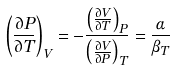Convert formula to latex. <formula><loc_0><loc_0><loc_500><loc_500>\left ( { \frac { \partial P } { \partial T } } \right ) _ { V } = - { \frac { \left ( { \frac { \partial V } { \partial T } } \right ) _ { P } } { \left ( { \frac { \partial V } { \partial P } } \right ) _ { T } } } = { \frac { \alpha } { \beta _ { T } } }</formula> 